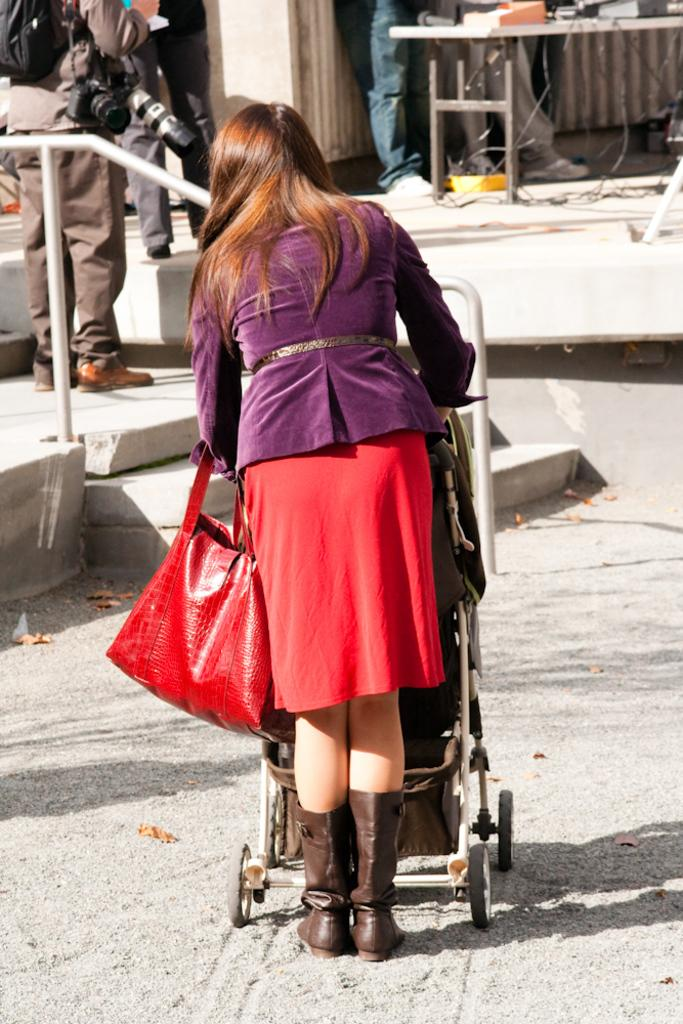Who is the main subject in the image? There is a woman in the image. What is the woman doing in the image? The woman is standing behind a trolley and pushing it. What is the woman holding in her hand? The woman is holding a red bag in her hand. What can be seen in the background of the image? There is a railing in the image. Are there any other people present in the image? Yes, there are people present in the image. What type of shoes is the woman wearing in the image? There is no information about the woman's shoes in the image. 